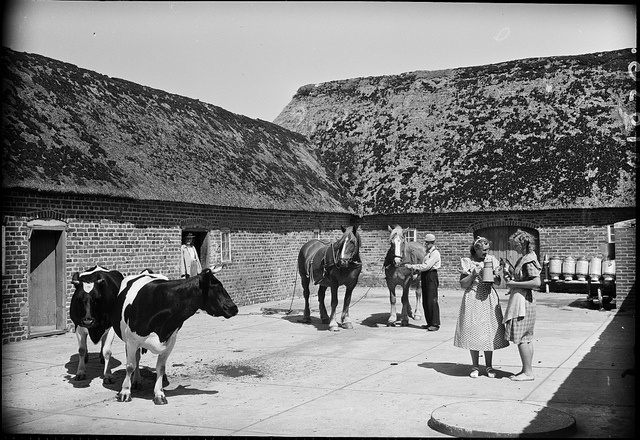Describe the objects in this image and their specific colors. I can see cow in black, darkgray, lightgray, and gray tones, people in black, lightgray, darkgray, and gray tones, horse in black, gray, darkgray, and lightgray tones, people in black, darkgray, gray, and lightgray tones, and cow in black, gray, lightgray, and darkgray tones in this image. 